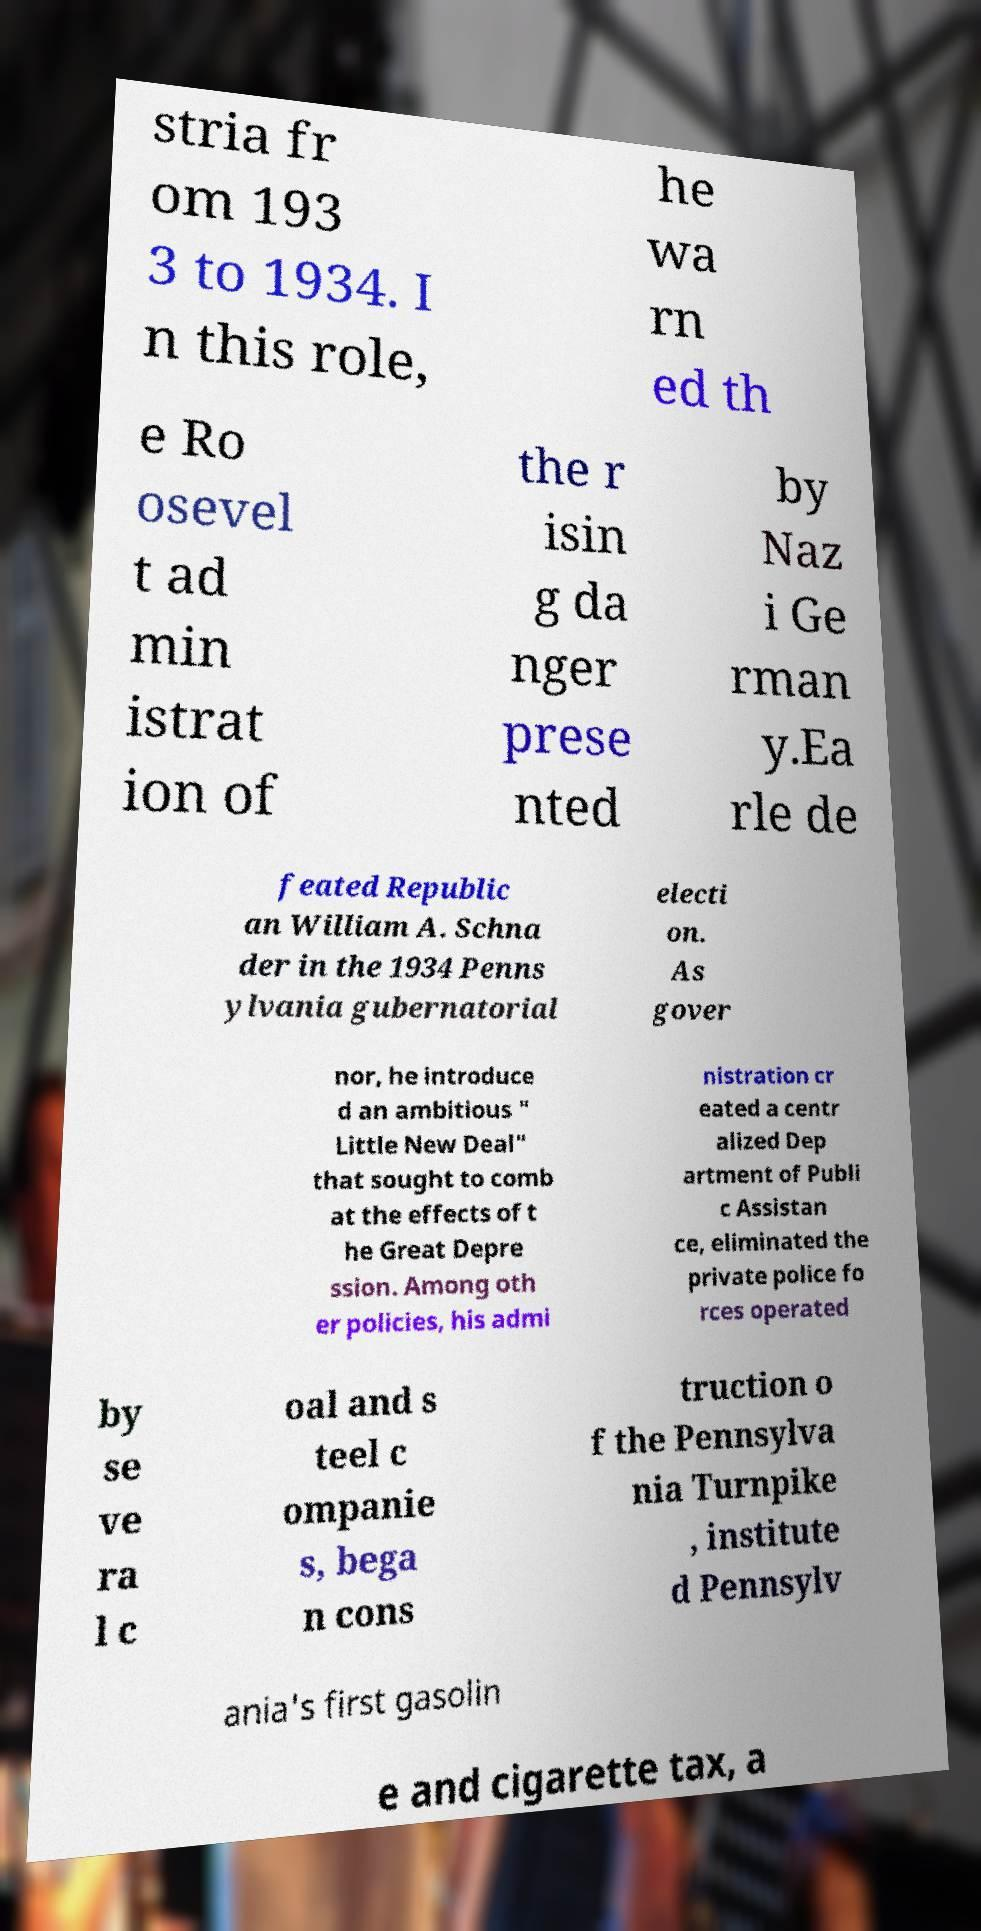I need the written content from this picture converted into text. Can you do that? stria fr om 193 3 to 1934. I n this role, he wa rn ed th e Ro osevel t ad min istrat ion of the r isin g da nger prese nted by Naz i Ge rman y.Ea rle de feated Republic an William A. Schna der in the 1934 Penns ylvania gubernatorial electi on. As gover nor, he introduce d an ambitious " Little New Deal" that sought to comb at the effects of t he Great Depre ssion. Among oth er policies, his admi nistration cr eated a centr alized Dep artment of Publi c Assistan ce, eliminated the private police fo rces operated by se ve ra l c oal and s teel c ompanie s, bega n cons truction o f the Pennsylva nia Turnpike , institute d Pennsylv ania's first gasolin e and cigarette tax, a 